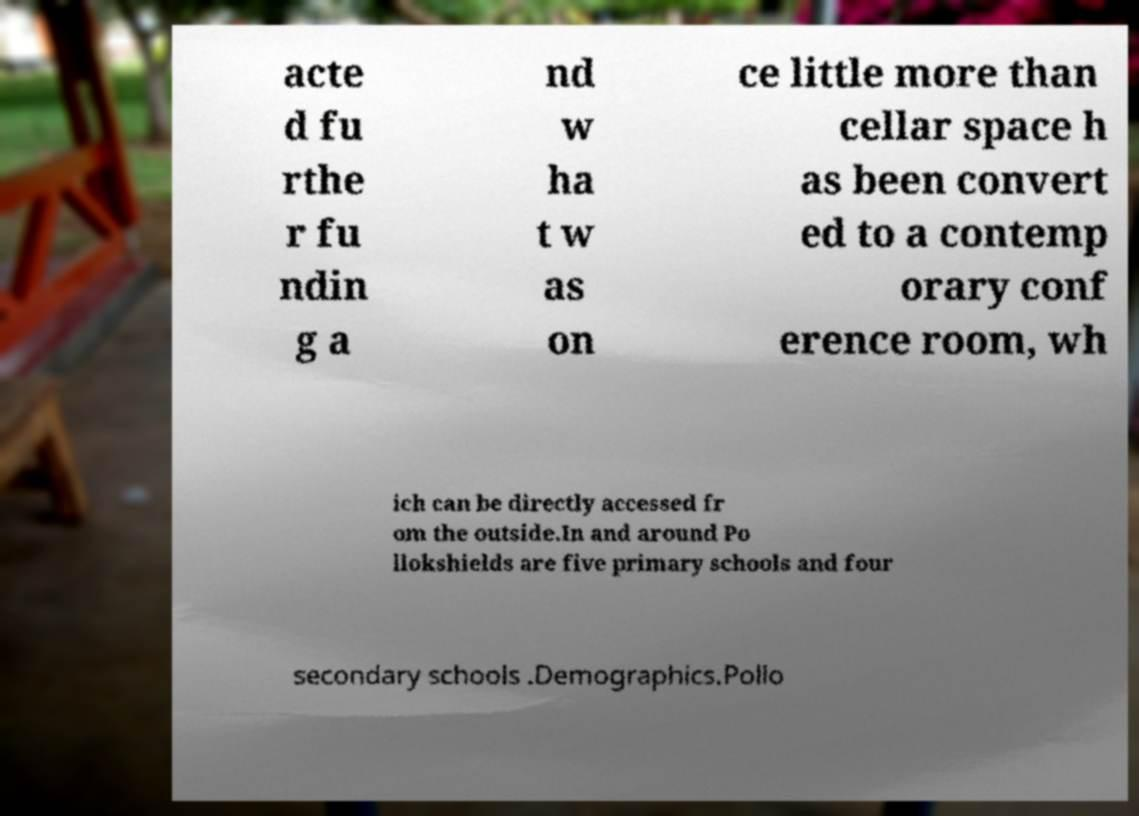There's text embedded in this image that I need extracted. Can you transcribe it verbatim? acte d fu rthe r fu ndin g a nd w ha t w as on ce little more than cellar space h as been convert ed to a contemp orary conf erence room, wh ich can be directly accessed fr om the outside.In and around Po llokshields are five primary schools and four secondary schools .Demographics.Pollo 